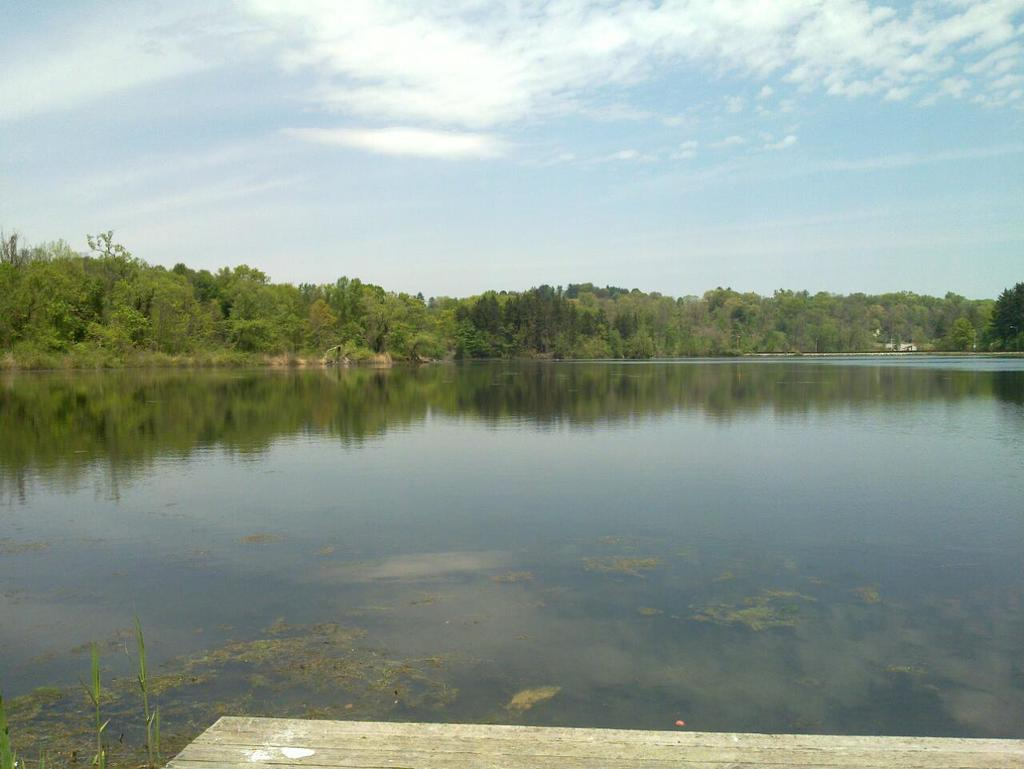What is the main subject in the center of the image? There is water in the center of the image. What can be seen in the background of the image? There are trees in the background of the image. What is visible at the top of the image? The sky is visible at the top of the image. What is the beginner's level of the game being played in the image? There is no game being played in the image, so it is not possible to determine the beginner's level. 